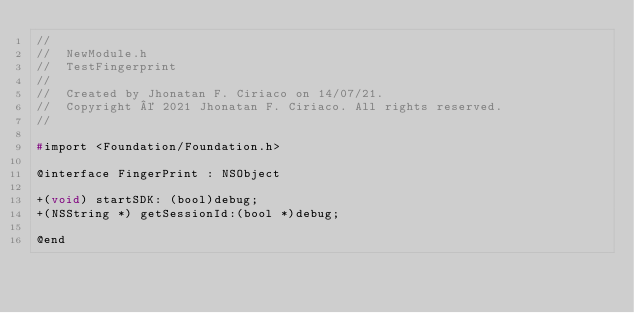Convert code to text. <code><loc_0><loc_0><loc_500><loc_500><_C_>//
//  NewModule.h
//  TestFingerprint
//
//  Created by Jhonatan F. Ciriaco on 14/07/21.
//  Copyright © 2021 Jhonatan F. Ciriaco. All rights reserved.
//

#import <Foundation/Foundation.h>

@interface FingerPrint : NSObject

+(void) startSDK: (bool)debug;
+(NSString *) getSessionId:(bool *)debug;

@end
</code> 